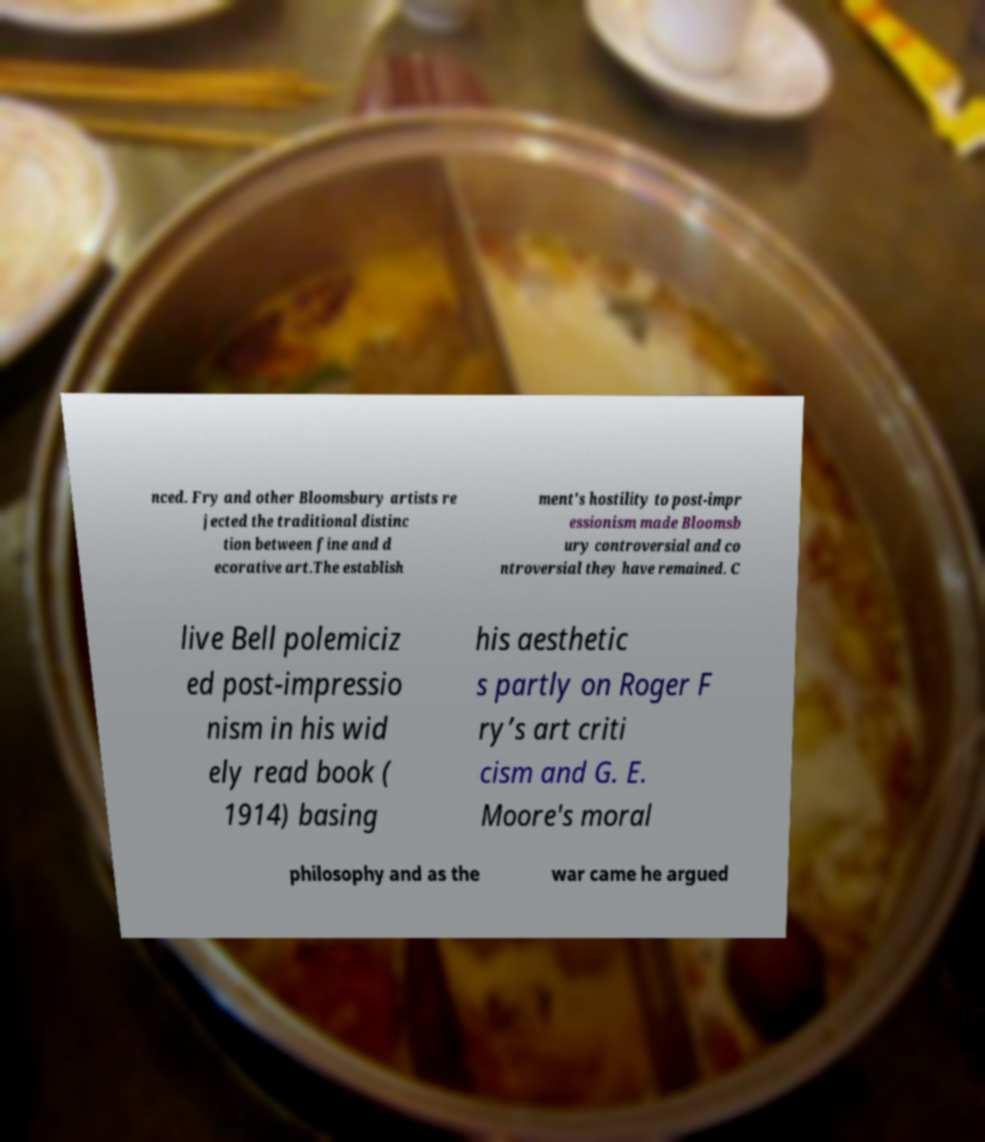There's text embedded in this image that I need extracted. Can you transcribe it verbatim? nced. Fry and other Bloomsbury artists re jected the traditional distinc tion between fine and d ecorative art.The establish ment's hostility to post-impr essionism made Bloomsb ury controversial and co ntroversial they have remained. C live Bell polemiciz ed post-impressio nism in his wid ely read book ( 1914) basing his aesthetic s partly on Roger F ry’s art criti cism and G. E. Moore's moral philosophy and as the war came he argued 